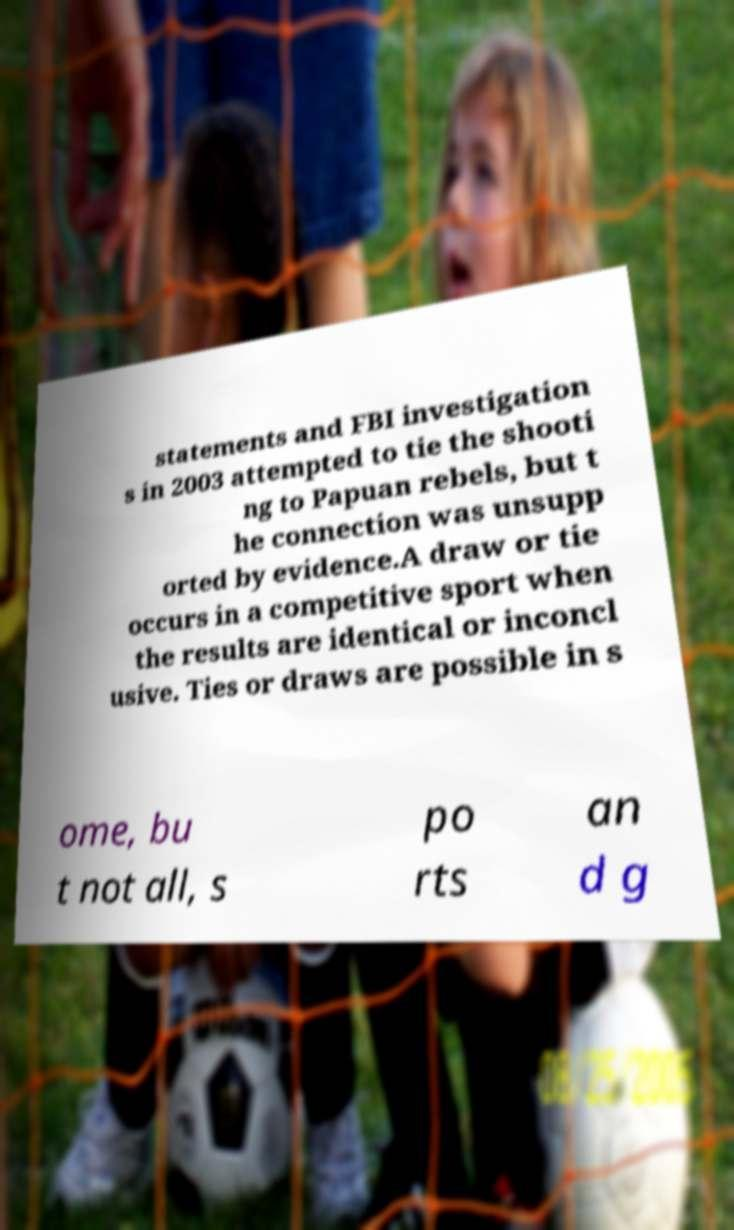I need the written content from this picture converted into text. Can you do that? statements and FBI investigation s in 2003 attempted to tie the shooti ng to Papuan rebels, but t he connection was unsupp orted by evidence.A draw or tie occurs in a competitive sport when the results are identical or inconcl usive. Ties or draws are possible in s ome, bu t not all, s po rts an d g 